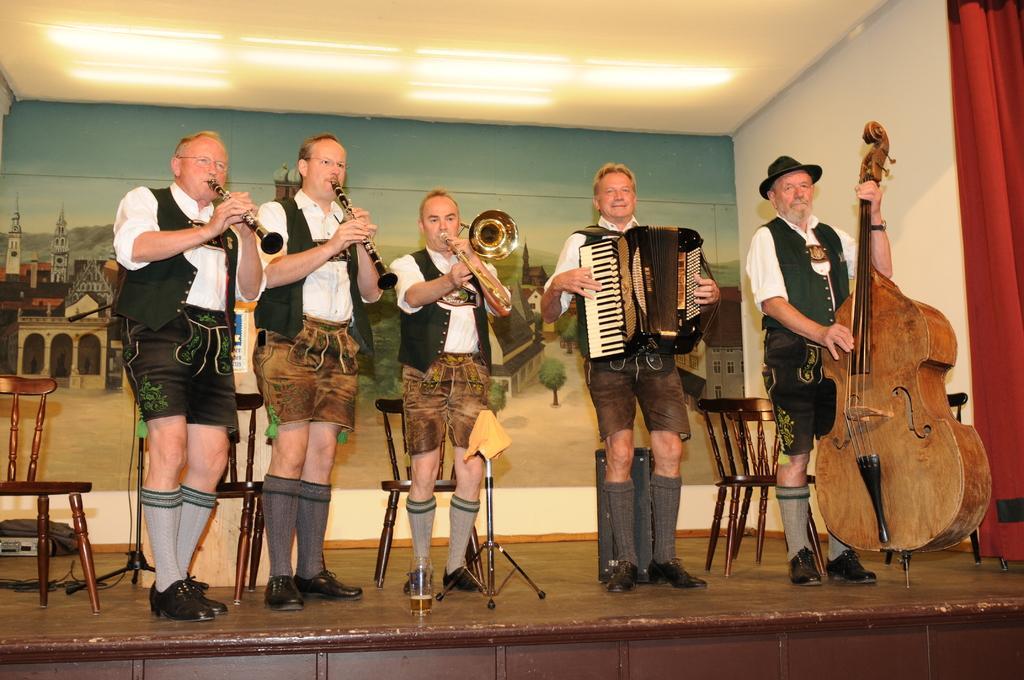Describe this image in one or two sentences. This image is taken indoors. At the top of the image there is a dais. In the middle of the image five men are standing on the dais and playing music with the musical instruments. In the background there are a few empty chairs and there is a wall with a painting on it. At the top of the image there is a ceiling with lights. On the right side of the image there is a curtain. 